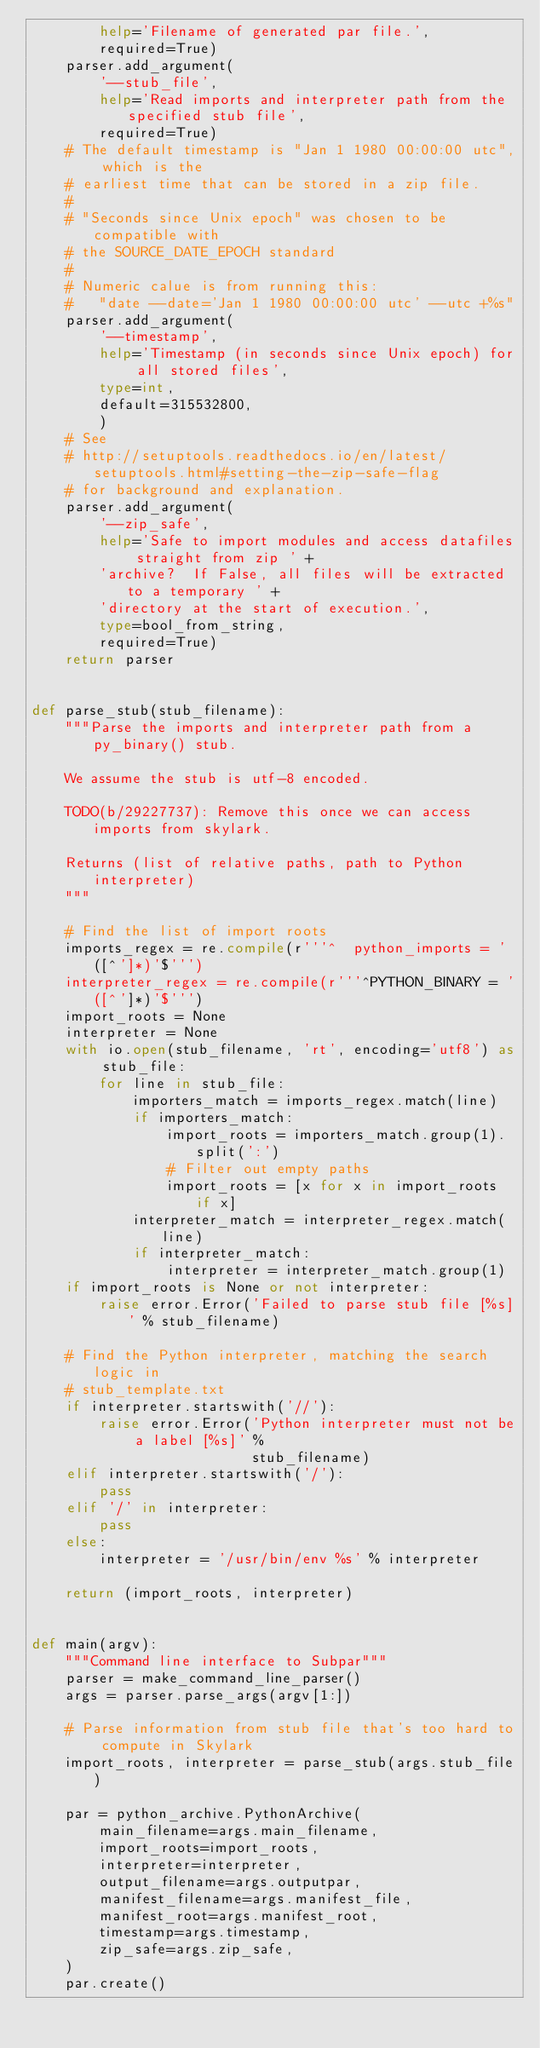Convert code to text. <code><loc_0><loc_0><loc_500><loc_500><_Python_>        help='Filename of generated par file.',
        required=True)
    parser.add_argument(
        '--stub_file',
        help='Read imports and interpreter path from the specified stub file',
        required=True)
    # The default timestamp is "Jan 1 1980 00:00:00 utc", which is the
    # earliest time that can be stored in a zip file.
    #
    # "Seconds since Unix epoch" was chosen to be compatible with
    # the SOURCE_DATE_EPOCH standard
    #
    # Numeric calue is from running this:
    #   "date --date='Jan 1 1980 00:00:00 utc' --utc +%s"
    parser.add_argument(
        '--timestamp',
        help='Timestamp (in seconds since Unix epoch) for all stored files',
        type=int,
        default=315532800,
        )
    # See
    # http://setuptools.readthedocs.io/en/latest/setuptools.html#setting-the-zip-safe-flag
    # for background and explanation.
    parser.add_argument(
        '--zip_safe',
        help='Safe to import modules and access datafiles straight from zip ' +
        'archive?  If False, all files will be extracted to a temporary ' +
        'directory at the start of execution.',
        type=bool_from_string,
        required=True)
    return parser


def parse_stub(stub_filename):
    """Parse the imports and interpreter path from a py_binary() stub.

    We assume the stub is utf-8 encoded.

    TODO(b/29227737): Remove this once we can access imports from skylark.

    Returns (list of relative paths, path to Python interpreter)
    """

    # Find the list of import roots
    imports_regex = re.compile(r'''^  python_imports = '([^']*)'$''')
    interpreter_regex = re.compile(r'''^PYTHON_BINARY = '([^']*)'$''')
    import_roots = None
    interpreter = None
    with io.open(stub_filename, 'rt', encoding='utf8') as stub_file:
        for line in stub_file:
            importers_match = imports_regex.match(line)
            if importers_match:
                import_roots = importers_match.group(1).split(':')
                # Filter out empty paths
                import_roots = [x for x in import_roots if x]
            interpreter_match = interpreter_regex.match(line)
            if interpreter_match:
                interpreter = interpreter_match.group(1)
    if import_roots is None or not interpreter:
        raise error.Error('Failed to parse stub file [%s]' % stub_filename)

    # Find the Python interpreter, matching the search logic in
    # stub_template.txt
    if interpreter.startswith('//'):
        raise error.Error('Python interpreter must not be a label [%s]' %
                          stub_filename)
    elif interpreter.startswith('/'):
        pass
    elif '/' in interpreter:
        pass
    else:
        interpreter = '/usr/bin/env %s' % interpreter

    return (import_roots, interpreter)


def main(argv):
    """Command line interface to Subpar"""
    parser = make_command_line_parser()
    args = parser.parse_args(argv[1:])

    # Parse information from stub file that's too hard to compute in Skylark
    import_roots, interpreter = parse_stub(args.stub_file)

    par = python_archive.PythonArchive(
        main_filename=args.main_filename,
        import_roots=import_roots,
        interpreter=interpreter,
        output_filename=args.outputpar,
        manifest_filename=args.manifest_file,
        manifest_root=args.manifest_root,
        timestamp=args.timestamp,
        zip_safe=args.zip_safe,
    )
    par.create()
</code> 